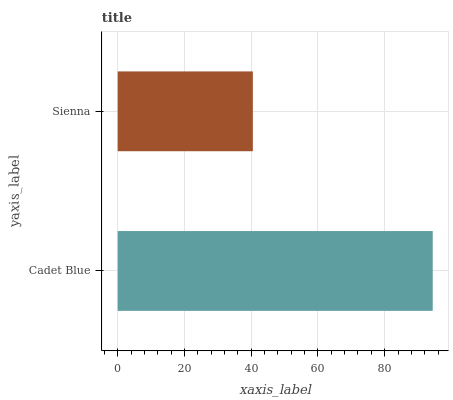Is Sienna the minimum?
Answer yes or no. Yes. Is Cadet Blue the maximum?
Answer yes or no. Yes. Is Sienna the maximum?
Answer yes or no. No. Is Cadet Blue greater than Sienna?
Answer yes or no. Yes. Is Sienna less than Cadet Blue?
Answer yes or no. Yes. Is Sienna greater than Cadet Blue?
Answer yes or no. No. Is Cadet Blue less than Sienna?
Answer yes or no. No. Is Cadet Blue the high median?
Answer yes or no. Yes. Is Sienna the low median?
Answer yes or no. Yes. Is Sienna the high median?
Answer yes or no. No. Is Cadet Blue the low median?
Answer yes or no. No. 